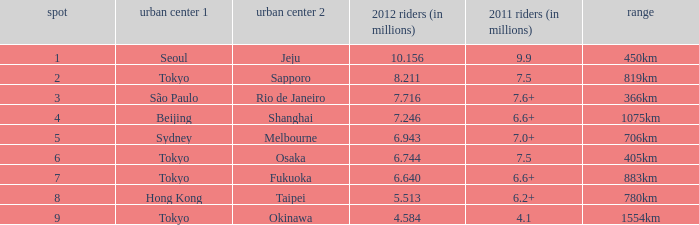How many passengers (in millions) flew through along the route that is 1075km long in 2012? 7.246. 